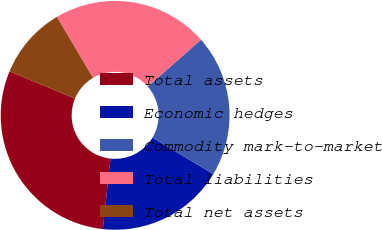Convert chart. <chart><loc_0><loc_0><loc_500><loc_500><pie_chart><fcel>Total assets<fcel>Economic hedges<fcel>Commodity mark-to-market<fcel>Total liabilities<fcel>Total net assets<nl><fcel>29.57%<fcel>18.14%<fcel>20.07%<fcel>22.01%<fcel>10.21%<nl></chart> 